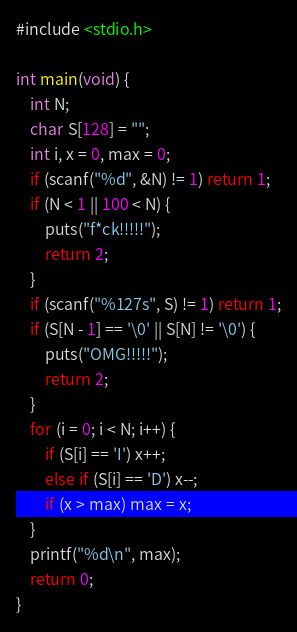Convert code to text. <code><loc_0><loc_0><loc_500><loc_500><_C_>#include <stdio.h>

int main(void) {
	int N;
	char S[128] = "";
	int i, x = 0, max = 0;
	if (scanf("%d", &N) != 1) return 1;
	if (N < 1 || 100 < N) {
		puts("f*ck!!!!!");
		return 2;
	}
	if (scanf("%127s", S) != 1) return 1;
	if (S[N - 1] == '\0' || S[N] != '\0') {
		puts("OMG!!!!!");
		return 2;
	}
	for (i = 0; i < N; i++) {
		if (S[i] == 'I') x++;
		else if (S[i] == 'D') x--;
		if (x > max) max = x;
	}
	printf("%d\n", max);
	return 0;
}
</code> 